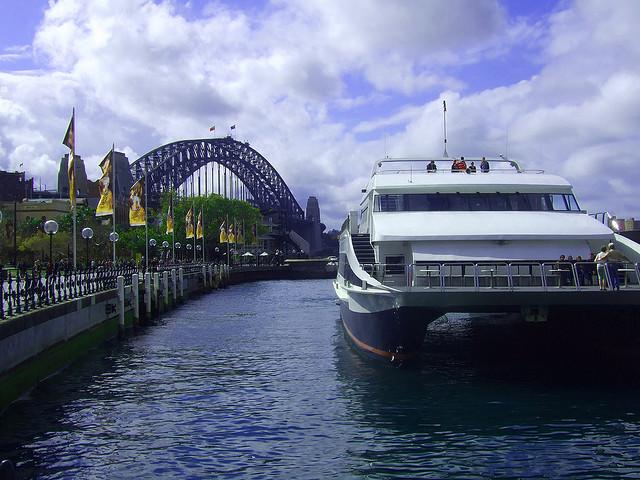Can you swim here?
Quick response, please. No. How many flags are pictured?
Short answer required. 8. Are there people on the boat?
Keep it brief. Yes. 